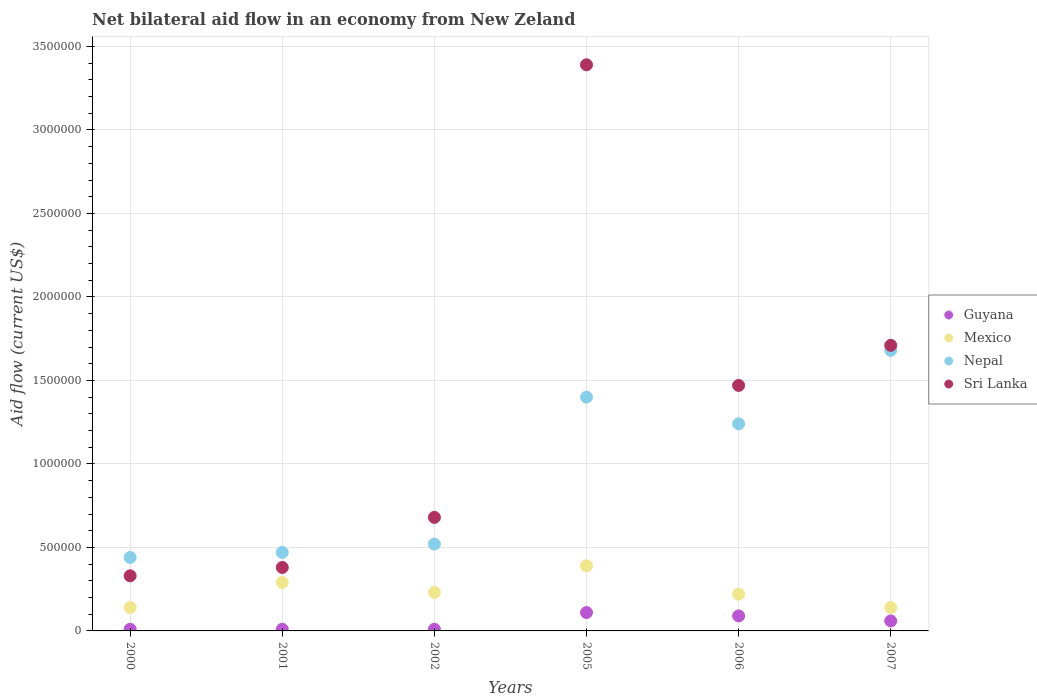What is the net bilateral aid flow in Guyana in 2002?
Offer a terse response. 10000. Across all years, what is the maximum net bilateral aid flow in Sri Lanka?
Provide a short and direct response. 3.39e+06. In which year was the net bilateral aid flow in Mexico maximum?
Your answer should be compact. 2005. In which year was the net bilateral aid flow in Mexico minimum?
Your answer should be very brief. 2000. What is the total net bilateral aid flow in Nepal in the graph?
Your answer should be very brief. 5.75e+06. What is the difference between the net bilateral aid flow in Sri Lanka in 2002 and that in 2005?
Your answer should be compact. -2.71e+06. What is the difference between the net bilateral aid flow in Nepal in 2005 and the net bilateral aid flow in Guyana in 2001?
Offer a very short reply. 1.39e+06. What is the average net bilateral aid flow in Sri Lanka per year?
Provide a succinct answer. 1.33e+06. What is the ratio of the net bilateral aid flow in Guyana in 2000 to that in 2005?
Offer a terse response. 0.09. What is the difference between the highest and the second highest net bilateral aid flow in Sri Lanka?
Your answer should be very brief. 1.68e+06. What is the difference between the highest and the lowest net bilateral aid flow in Nepal?
Your answer should be compact. 1.24e+06. Is the sum of the net bilateral aid flow in Nepal in 2001 and 2002 greater than the maximum net bilateral aid flow in Guyana across all years?
Ensure brevity in your answer.  Yes. Is it the case that in every year, the sum of the net bilateral aid flow in Mexico and net bilateral aid flow in Nepal  is greater than the sum of net bilateral aid flow in Guyana and net bilateral aid flow in Sri Lanka?
Provide a succinct answer. Yes. Does the net bilateral aid flow in Guyana monotonically increase over the years?
Your answer should be very brief. No. Is the net bilateral aid flow in Nepal strictly greater than the net bilateral aid flow in Guyana over the years?
Offer a terse response. Yes. How many dotlines are there?
Keep it short and to the point. 4. What is the difference between two consecutive major ticks on the Y-axis?
Offer a terse response. 5.00e+05. Does the graph contain any zero values?
Offer a terse response. No. What is the title of the graph?
Offer a terse response. Net bilateral aid flow in an economy from New Zeland. What is the Aid flow (current US$) in Guyana in 2000?
Make the answer very short. 10000. What is the Aid flow (current US$) of Mexico in 2000?
Keep it short and to the point. 1.40e+05. What is the Aid flow (current US$) in Nepal in 2000?
Your response must be concise. 4.40e+05. What is the Aid flow (current US$) in Sri Lanka in 2001?
Your response must be concise. 3.80e+05. What is the Aid flow (current US$) in Mexico in 2002?
Offer a terse response. 2.30e+05. What is the Aid flow (current US$) in Nepal in 2002?
Provide a succinct answer. 5.20e+05. What is the Aid flow (current US$) in Sri Lanka in 2002?
Your answer should be very brief. 6.80e+05. What is the Aid flow (current US$) in Guyana in 2005?
Offer a terse response. 1.10e+05. What is the Aid flow (current US$) in Nepal in 2005?
Your answer should be very brief. 1.40e+06. What is the Aid flow (current US$) of Sri Lanka in 2005?
Your answer should be very brief. 3.39e+06. What is the Aid flow (current US$) of Guyana in 2006?
Offer a very short reply. 9.00e+04. What is the Aid flow (current US$) of Nepal in 2006?
Keep it short and to the point. 1.24e+06. What is the Aid flow (current US$) in Sri Lanka in 2006?
Your response must be concise. 1.47e+06. What is the Aid flow (current US$) of Mexico in 2007?
Offer a very short reply. 1.40e+05. What is the Aid flow (current US$) in Nepal in 2007?
Ensure brevity in your answer.  1.68e+06. What is the Aid flow (current US$) in Sri Lanka in 2007?
Your response must be concise. 1.71e+06. Across all years, what is the maximum Aid flow (current US$) in Nepal?
Give a very brief answer. 1.68e+06. Across all years, what is the maximum Aid flow (current US$) in Sri Lanka?
Provide a succinct answer. 3.39e+06. Across all years, what is the minimum Aid flow (current US$) of Nepal?
Give a very brief answer. 4.40e+05. Across all years, what is the minimum Aid flow (current US$) of Sri Lanka?
Ensure brevity in your answer.  3.30e+05. What is the total Aid flow (current US$) of Guyana in the graph?
Your answer should be very brief. 2.90e+05. What is the total Aid flow (current US$) in Mexico in the graph?
Ensure brevity in your answer.  1.41e+06. What is the total Aid flow (current US$) in Nepal in the graph?
Provide a succinct answer. 5.75e+06. What is the total Aid flow (current US$) of Sri Lanka in the graph?
Offer a terse response. 7.96e+06. What is the difference between the Aid flow (current US$) of Nepal in 2000 and that in 2001?
Provide a succinct answer. -3.00e+04. What is the difference between the Aid flow (current US$) in Nepal in 2000 and that in 2002?
Provide a short and direct response. -8.00e+04. What is the difference between the Aid flow (current US$) in Sri Lanka in 2000 and that in 2002?
Offer a very short reply. -3.50e+05. What is the difference between the Aid flow (current US$) of Nepal in 2000 and that in 2005?
Provide a succinct answer. -9.60e+05. What is the difference between the Aid flow (current US$) in Sri Lanka in 2000 and that in 2005?
Make the answer very short. -3.06e+06. What is the difference between the Aid flow (current US$) in Guyana in 2000 and that in 2006?
Offer a terse response. -8.00e+04. What is the difference between the Aid flow (current US$) in Nepal in 2000 and that in 2006?
Your answer should be compact. -8.00e+05. What is the difference between the Aid flow (current US$) in Sri Lanka in 2000 and that in 2006?
Give a very brief answer. -1.14e+06. What is the difference between the Aid flow (current US$) in Nepal in 2000 and that in 2007?
Your answer should be compact. -1.24e+06. What is the difference between the Aid flow (current US$) in Sri Lanka in 2000 and that in 2007?
Offer a very short reply. -1.38e+06. What is the difference between the Aid flow (current US$) in Mexico in 2001 and that in 2002?
Make the answer very short. 6.00e+04. What is the difference between the Aid flow (current US$) in Sri Lanka in 2001 and that in 2002?
Keep it short and to the point. -3.00e+05. What is the difference between the Aid flow (current US$) of Guyana in 2001 and that in 2005?
Keep it short and to the point. -1.00e+05. What is the difference between the Aid flow (current US$) in Nepal in 2001 and that in 2005?
Provide a short and direct response. -9.30e+05. What is the difference between the Aid flow (current US$) of Sri Lanka in 2001 and that in 2005?
Keep it short and to the point. -3.01e+06. What is the difference between the Aid flow (current US$) in Guyana in 2001 and that in 2006?
Provide a succinct answer. -8.00e+04. What is the difference between the Aid flow (current US$) of Mexico in 2001 and that in 2006?
Your answer should be very brief. 7.00e+04. What is the difference between the Aid flow (current US$) in Nepal in 2001 and that in 2006?
Your response must be concise. -7.70e+05. What is the difference between the Aid flow (current US$) of Sri Lanka in 2001 and that in 2006?
Ensure brevity in your answer.  -1.09e+06. What is the difference between the Aid flow (current US$) in Mexico in 2001 and that in 2007?
Offer a very short reply. 1.50e+05. What is the difference between the Aid flow (current US$) in Nepal in 2001 and that in 2007?
Your answer should be very brief. -1.21e+06. What is the difference between the Aid flow (current US$) in Sri Lanka in 2001 and that in 2007?
Make the answer very short. -1.33e+06. What is the difference between the Aid flow (current US$) in Guyana in 2002 and that in 2005?
Provide a short and direct response. -1.00e+05. What is the difference between the Aid flow (current US$) of Mexico in 2002 and that in 2005?
Provide a short and direct response. -1.60e+05. What is the difference between the Aid flow (current US$) of Nepal in 2002 and that in 2005?
Offer a very short reply. -8.80e+05. What is the difference between the Aid flow (current US$) in Sri Lanka in 2002 and that in 2005?
Offer a terse response. -2.71e+06. What is the difference between the Aid flow (current US$) of Guyana in 2002 and that in 2006?
Provide a short and direct response. -8.00e+04. What is the difference between the Aid flow (current US$) of Nepal in 2002 and that in 2006?
Offer a very short reply. -7.20e+05. What is the difference between the Aid flow (current US$) of Sri Lanka in 2002 and that in 2006?
Provide a succinct answer. -7.90e+05. What is the difference between the Aid flow (current US$) of Guyana in 2002 and that in 2007?
Your answer should be compact. -5.00e+04. What is the difference between the Aid flow (current US$) of Nepal in 2002 and that in 2007?
Make the answer very short. -1.16e+06. What is the difference between the Aid flow (current US$) in Sri Lanka in 2002 and that in 2007?
Offer a terse response. -1.03e+06. What is the difference between the Aid flow (current US$) of Nepal in 2005 and that in 2006?
Give a very brief answer. 1.60e+05. What is the difference between the Aid flow (current US$) in Sri Lanka in 2005 and that in 2006?
Keep it short and to the point. 1.92e+06. What is the difference between the Aid flow (current US$) in Nepal in 2005 and that in 2007?
Make the answer very short. -2.80e+05. What is the difference between the Aid flow (current US$) in Sri Lanka in 2005 and that in 2007?
Your answer should be compact. 1.68e+06. What is the difference between the Aid flow (current US$) in Guyana in 2006 and that in 2007?
Give a very brief answer. 3.00e+04. What is the difference between the Aid flow (current US$) in Nepal in 2006 and that in 2007?
Your answer should be compact. -4.40e+05. What is the difference between the Aid flow (current US$) of Sri Lanka in 2006 and that in 2007?
Keep it short and to the point. -2.40e+05. What is the difference between the Aid flow (current US$) in Guyana in 2000 and the Aid flow (current US$) in Mexico in 2001?
Make the answer very short. -2.80e+05. What is the difference between the Aid flow (current US$) of Guyana in 2000 and the Aid flow (current US$) of Nepal in 2001?
Make the answer very short. -4.60e+05. What is the difference between the Aid flow (current US$) of Guyana in 2000 and the Aid flow (current US$) of Sri Lanka in 2001?
Give a very brief answer. -3.70e+05. What is the difference between the Aid flow (current US$) of Mexico in 2000 and the Aid flow (current US$) of Nepal in 2001?
Keep it short and to the point. -3.30e+05. What is the difference between the Aid flow (current US$) in Nepal in 2000 and the Aid flow (current US$) in Sri Lanka in 2001?
Provide a succinct answer. 6.00e+04. What is the difference between the Aid flow (current US$) of Guyana in 2000 and the Aid flow (current US$) of Nepal in 2002?
Your answer should be very brief. -5.10e+05. What is the difference between the Aid flow (current US$) in Guyana in 2000 and the Aid flow (current US$) in Sri Lanka in 2002?
Your answer should be very brief. -6.70e+05. What is the difference between the Aid flow (current US$) of Mexico in 2000 and the Aid flow (current US$) of Nepal in 2002?
Ensure brevity in your answer.  -3.80e+05. What is the difference between the Aid flow (current US$) in Mexico in 2000 and the Aid flow (current US$) in Sri Lanka in 2002?
Make the answer very short. -5.40e+05. What is the difference between the Aid flow (current US$) of Nepal in 2000 and the Aid flow (current US$) of Sri Lanka in 2002?
Your answer should be very brief. -2.40e+05. What is the difference between the Aid flow (current US$) in Guyana in 2000 and the Aid flow (current US$) in Mexico in 2005?
Provide a short and direct response. -3.80e+05. What is the difference between the Aid flow (current US$) of Guyana in 2000 and the Aid flow (current US$) of Nepal in 2005?
Give a very brief answer. -1.39e+06. What is the difference between the Aid flow (current US$) in Guyana in 2000 and the Aid flow (current US$) in Sri Lanka in 2005?
Offer a terse response. -3.38e+06. What is the difference between the Aid flow (current US$) of Mexico in 2000 and the Aid flow (current US$) of Nepal in 2005?
Ensure brevity in your answer.  -1.26e+06. What is the difference between the Aid flow (current US$) of Mexico in 2000 and the Aid flow (current US$) of Sri Lanka in 2005?
Provide a succinct answer. -3.25e+06. What is the difference between the Aid flow (current US$) in Nepal in 2000 and the Aid flow (current US$) in Sri Lanka in 2005?
Your answer should be very brief. -2.95e+06. What is the difference between the Aid flow (current US$) in Guyana in 2000 and the Aid flow (current US$) in Nepal in 2006?
Ensure brevity in your answer.  -1.23e+06. What is the difference between the Aid flow (current US$) in Guyana in 2000 and the Aid flow (current US$) in Sri Lanka in 2006?
Provide a short and direct response. -1.46e+06. What is the difference between the Aid flow (current US$) of Mexico in 2000 and the Aid flow (current US$) of Nepal in 2006?
Your response must be concise. -1.10e+06. What is the difference between the Aid flow (current US$) of Mexico in 2000 and the Aid flow (current US$) of Sri Lanka in 2006?
Your response must be concise. -1.33e+06. What is the difference between the Aid flow (current US$) of Nepal in 2000 and the Aid flow (current US$) of Sri Lanka in 2006?
Your answer should be very brief. -1.03e+06. What is the difference between the Aid flow (current US$) of Guyana in 2000 and the Aid flow (current US$) of Nepal in 2007?
Your answer should be very brief. -1.67e+06. What is the difference between the Aid flow (current US$) in Guyana in 2000 and the Aid flow (current US$) in Sri Lanka in 2007?
Provide a succinct answer. -1.70e+06. What is the difference between the Aid flow (current US$) in Mexico in 2000 and the Aid flow (current US$) in Nepal in 2007?
Offer a very short reply. -1.54e+06. What is the difference between the Aid flow (current US$) of Mexico in 2000 and the Aid flow (current US$) of Sri Lanka in 2007?
Your response must be concise. -1.57e+06. What is the difference between the Aid flow (current US$) of Nepal in 2000 and the Aid flow (current US$) of Sri Lanka in 2007?
Give a very brief answer. -1.27e+06. What is the difference between the Aid flow (current US$) in Guyana in 2001 and the Aid flow (current US$) in Mexico in 2002?
Keep it short and to the point. -2.20e+05. What is the difference between the Aid flow (current US$) in Guyana in 2001 and the Aid flow (current US$) in Nepal in 2002?
Ensure brevity in your answer.  -5.10e+05. What is the difference between the Aid flow (current US$) in Guyana in 2001 and the Aid flow (current US$) in Sri Lanka in 2002?
Keep it short and to the point. -6.70e+05. What is the difference between the Aid flow (current US$) in Mexico in 2001 and the Aid flow (current US$) in Nepal in 2002?
Keep it short and to the point. -2.30e+05. What is the difference between the Aid flow (current US$) of Mexico in 2001 and the Aid flow (current US$) of Sri Lanka in 2002?
Provide a short and direct response. -3.90e+05. What is the difference between the Aid flow (current US$) of Guyana in 2001 and the Aid flow (current US$) of Mexico in 2005?
Your answer should be compact. -3.80e+05. What is the difference between the Aid flow (current US$) in Guyana in 2001 and the Aid flow (current US$) in Nepal in 2005?
Make the answer very short. -1.39e+06. What is the difference between the Aid flow (current US$) of Guyana in 2001 and the Aid flow (current US$) of Sri Lanka in 2005?
Provide a succinct answer. -3.38e+06. What is the difference between the Aid flow (current US$) in Mexico in 2001 and the Aid flow (current US$) in Nepal in 2005?
Your answer should be compact. -1.11e+06. What is the difference between the Aid flow (current US$) of Mexico in 2001 and the Aid flow (current US$) of Sri Lanka in 2005?
Keep it short and to the point. -3.10e+06. What is the difference between the Aid flow (current US$) in Nepal in 2001 and the Aid flow (current US$) in Sri Lanka in 2005?
Ensure brevity in your answer.  -2.92e+06. What is the difference between the Aid flow (current US$) in Guyana in 2001 and the Aid flow (current US$) in Mexico in 2006?
Give a very brief answer. -2.10e+05. What is the difference between the Aid flow (current US$) of Guyana in 2001 and the Aid flow (current US$) of Nepal in 2006?
Make the answer very short. -1.23e+06. What is the difference between the Aid flow (current US$) in Guyana in 2001 and the Aid flow (current US$) in Sri Lanka in 2006?
Keep it short and to the point. -1.46e+06. What is the difference between the Aid flow (current US$) of Mexico in 2001 and the Aid flow (current US$) of Nepal in 2006?
Ensure brevity in your answer.  -9.50e+05. What is the difference between the Aid flow (current US$) in Mexico in 2001 and the Aid flow (current US$) in Sri Lanka in 2006?
Your response must be concise. -1.18e+06. What is the difference between the Aid flow (current US$) in Guyana in 2001 and the Aid flow (current US$) in Mexico in 2007?
Offer a terse response. -1.30e+05. What is the difference between the Aid flow (current US$) of Guyana in 2001 and the Aid flow (current US$) of Nepal in 2007?
Your answer should be compact. -1.67e+06. What is the difference between the Aid flow (current US$) of Guyana in 2001 and the Aid flow (current US$) of Sri Lanka in 2007?
Offer a very short reply. -1.70e+06. What is the difference between the Aid flow (current US$) in Mexico in 2001 and the Aid flow (current US$) in Nepal in 2007?
Provide a short and direct response. -1.39e+06. What is the difference between the Aid flow (current US$) in Mexico in 2001 and the Aid flow (current US$) in Sri Lanka in 2007?
Your response must be concise. -1.42e+06. What is the difference between the Aid flow (current US$) of Nepal in 2001 and the Aid flow (current US$) of Sri Lanka in 2007?
Offer a terse response. -1.24e+06. What is the difference between the Aid flow (current US$) in Guyana in 2002 and the Aid flow (current US$) in Mexico in 2005?
Make the answer very short. -3.80e+05. What is the difference between the Aid flow (current US$) of Guyana in 2002 and the Aid flow (current US$) of Nepal in 2005?
Your answer should be very brief. -1.39e+06. What is the difference between the Aid flow (current US$) of Guyana in 2002 and the Aid flow (current US$) of Sri Lanka in 2005?
Ensure brevity in your answer.  -3.38e+06. What is the difference between the Aid flow (current US$) of Mexico in 2002 and the Aid flow (current US$) of Nepal in 2005?
Offer a terse response. -1.17e+06. What is the difference between the Aid flow (current US$) of Mexico in 2002 and the Aid flow (current US$) of Sri Lanka in 2005?
Ensure brevity in your answer.  -3.16e+06. What is the difference between the Aid flow (current US$) in Nepal in 2002 and the Aid flow (current US$) in Sri Lanka in 2005?
Ensure brevity in your answer.  -2.87e+06. What is the difference between the Aid flow (current US$) in Guyana in 2002 and the Aid flow (current US$) in Mexico in 2006?
Offer a very short reply. -2.10e+05. What is the difference between the Aid flow (current US$) of Guyana in 2002 and the Aid flow (current US$) of Nepal in 2006?
Your answer should be very brief. -1.23e+06. What is the difference between the Aid flow (current US$) of Guyana in 2002 and the Aid flow (current US$) of Sri Lanka in 2006?
Provide a succinct answer. -1.46e+06. What is the difference between the Aid flow (current US$) in Mexico in 2002 and the Aid flow (current US$) in Nepal in 2006?
Provide a succinct answer. -1.01e+06. What is the difference between the Aid flow (current US$) of Mexico in 2002 and the Aid flow (current US$) of Sri Lanka in 2006?
Make the answer very short. -1.24e+06. What is the difference between the Aid flow (current US$) of Nepal in 2002 and the Aid flow (current US$) of Sri Lanka in 2006?
Ensure brevity in your answer.  -9.50e+05. What is the difference between the Aid flow (current US$) in Guyana in 2002 and the Aid flow (current US$) in Nepal in 2007?
Offer a very short reply. -1.67e+06. What is the difference between the Aid flow (current US$) in Guyana in 2002 and the Aid flow (current US$) in Sri Lanka in 2007?
Your answer should be compact. -1.70e+06. What is the difference between the Aid flow (current US$) of Mexico in 2002 and the Aid flow (current US$) of Nepal in 2007?
Ensure brevity in your answer.  -1.45e+06. What is the difference between the Aid flow (current US$) in Mexico in 2002 and the Aid flow (current US$) in Sri Lanka in 2007?
Offer a terse response. -1.48e+06. What is the difference between the Aid flow (current US$) of Nepal in 2002 and the Aid flow (current US$) of Sri Lanka in 2007?
Ensure brevity in your answer.  -1.19e+06. What is the difference between the Aid flow (current US$) of Guyana in 2005 and the Aid flow (current US$) of Nepal in 2006?
Offer a very short reply. -1.13e+06. What is the difference between the Aid flow (current US$) in Guyana in 2005 and the Aid flow (current US$) in Sri Lanka in 2006?
Offer a very short reply. -1.36e+06. What is the difference between the Aid flow (current US$) of Mexico in 2005 and the Aid flow (current US$) of Nepal in 2006?
Offer a terse response. -8.50e+05. What is the difference between the Aid flow (current US$) of Mexico in 2005 and the Aid flow (current US$) of Sri Lanka in 2006?
Keep it short and to the point. -1.08e+06. What is the difference between the Aid flow (current US$) of Guyana in 2005 and the Aid flow (current US$) of Mexico in 2007?
Keep it short and to the point. -3.00e+04. What is the difference between the Aid flow (current US$) of Guyana in 2005 and the Aid flow (current US$) of Nepal in 2007?
Keep it short and to the point. -1.57e+06. What is the difference between the Aid flow (current US$) in Guyana in 2005 and the Aid flow (current US$) in Sri Lanka in 2007?
Ensure brevity in your answer.  -1.60e+06. What is the difference between the Aid flow (current US$) in Mexico in 2005 and the Aid flow (current US$) in Nepal in 2007?
Ensure brevity in your answer.  -1.29e+06. What is the difference between the Aid flow (current US$) in Mexico in 2005 and the Aid flow (current US$) in Sri Lanka in 2007?
Provide a succinct answer. -1.32e+06. What is the difference between the Aid flow (current US$) of Nepal in 2005 and the Aid flow (current US$) of Sri Lanka in 2007?
Provide a succinct answer. -3.10e+05. What is the difference between the Aid flow (current US$) of Guyana in 2006 and the Aid flow (current US$) of Nepal in 2007?
Offer a very short reply. -1.59e+06. What is the difference between the Aid flow (current US$) of Guyana in 2006 and the Aid flow (current US$) of Sri Lanka in 2007?
Your response must be concise. -1.62e+06. What is the difference between the Aid flow (current US$) in Mexico in 2006 and the Aid flow (current US$) in Nepal in 2007?
Make the answer very short. -1.46e+06. What is the difference between the Aid flow (current US$) in Mexico in 2006 and the Aid flow (current US$) in Sri Lanka in 2007?
Offer a terse response. -1.49e+06. What is the difference between the Aid flow (current US$) in Nepal in 2006 and the Aid flow (current US$) in Sri Lanka in 2007?
Offer a terse response. -4.70e+05. What is the average Aid flow (current US$) of Guyana per year?
Your response must be concise. 4.83e+04. What is the average Aid flow (current US$) of Mexico per year?
Provide a short and direct response. 2.35e+05. What is the average Aid flow (current US$) in Nepal per year?
Provide a short and direct response. 9.58e+05. What is the average Aid flow (current US$) of Sri Lanka per year?
Make the answer very short. 1.33e+06. In the year 2000, what is the difference between the Aid flow (current US$) in Guyana and Aid flow (current US$) in Mexico?
Give a very brief answer. -1.30e+05. In the year 2000, what is the difference between the Aid flow (current US$) of Guyana and Aid flow (current US$) of Nepal?
Offer a very short reply. -4.30e+05. In the year 2000, what is the difference between the Aid flow (current US$) of Guyana and Aid flow (current US$) of Sri Lanka?
Your answer should be compact. -3.20e+05. In the year 2000, what is the difference between the Aid flow (current US$) in Nepal and Aid flow (current US$) in Sri Lanka?
Make the answer very short. 1.10e+05. In the year 2001, what is the difference between the Aid flow (current US$) of Guyana and Aid flow (current US$) of Mexico?
Offer a terse response. -2.80e+05. In the year 2001, what is the difference between the Aid flow (current US$) of Guyana and Aid flow (current US$) of Nepal?
Keep it short and to the point. -4.60e+05. In the year 2001, what is the difference between the Aid flow (current US$) in Guyana and Aid flow (current US$) in Sri Lanka?
Make the answer very short. -3.70e+05. In the year 2001, what is the difference between the Aid flow (current US$) in Mexico and Aid flow (current US$) in Nepal?
Keep it short and to the point. -1.80e+05. In the year 2001, what is the difference between the Aid flow (current US$) in Mexico and Aid flow (current US$) in Sri Lanka?
Give a very brief answer. -9.00e+04. In the year 2001, what is the difference between the Aid flow (current US$) in Nepal and Aid flow (current US$) in Sri Lanka?
Keep it short and to the point. 9.00e+04. In the year 2002, what is the difference between the Aid flow (current US$) of Guyana and Aid flow (current US$) of Mexico?
Your response must be concise. -2.20e+05. In the year 2002, what is the difference between the Aid flow (current US$) in Guyana and Aid flow (current US$) in Nepal?
Your answer should be very brief. -5.10e+05. In the year 2002, what is the difference between the Aid flow (current US$) of Guyana and Aid flow (current US$) of Sri Lanka?
Offer a very short reply. -6.70e+05. In the year 2002, what is the difference between the Aid flow (current US$) of Mexico and Aid flow (current US$) of Nepal?
Your response must be concise. -2.90e+05. In the year 2002, what is the difference between the Aid flow (current US$) of Mexico and Aid flow (current US$) of Sri Lanka?
Give a very brief answer. -4.50e+05. In the year 2005, what is the difference between the Aid flow (current US$) of Guyana and Aid flow (current US$) of Mexico?
Give a very brief answer. -2.80e+05. In the year 2005, what is the difference between the Aid flow (current US$) in Guyana and Aid flow (current US$) in Nepal?
Give a very brief answer. -1.29e+06. In the year 2005, what is the difference between the Aid flow (current US$) of Guyana and Aid flow (current US$) of Sri Lanka?
Offer a very short reply. -3.28e+06. In the year 2005, what is the difference between the Aid flow (current US$) in Mexico and Aid flow (current US$) in Nepal?
Ensure brevity in your answer.  -1.01e+06. In the year 2005, what is the difference between the Aid flow (current US$) in Mexico and Aid flow (current US$) in Sri Lanka?
Your answer should be very brief. -3.00e+06. In the year 2005, what is the difference between the Aid flow (current US$) in Nepal and Aid flow (current US$) in Sri Lanka?
Your answer should be compact. -1.99e+06. In the year 2006, what is the difference between the Aid flow (current US$) of Guyana and Aid flow (current US$) of Mexico?
Offer a very short reply. -1.30e+05. In the year 2006, what is the difference between the Aid flow (current US$) of Guyana and Aid flow (current US$) of Nepal?
Provide a succinct answer. -1.15e+06. In the year 2006, what is the difference between the Aid flow (current US$) in Guyana and Aid flow (current US$) in Sri Lanka?
Keep it short and to the point. -1.38e+06. In the year 2006, what is the difference between the Aid flow (current US$) of Mexico and Aid flow (current US$) of Nepal?
Provide a succinct answer. -1.02e+06. In the year 2006, what is the difference between the Aid flow (current US$) in Mexico and Aid flow (current US$) in Sri Lanka?
Provide a short and direct response. -1.25e+06. In the year 2006, what is the difference between the Aid flow (current US$) in Nepal and Aid flow (current US$) in Sri Lanka?
Offer a terse response. -2.30e+05. In the year 2007, what is the difference between the Aid flow (current US$) of Guyana and Aid flow (current US$) of Mexico?
Provide a short and direct response. -8.00e+04. In the year 2007, what is the difference between the Aid flow (current US$) in Guyana and Aid flow (current US$) in Nepal?
Provide a succinct answer. -1.62e+06. In the year 2007, what is the difference between the Aid flow (current US$) of Guyana and Aid flow (current US$) of Sri Lanka?
Provide a succinct answer. -1.65e+06. In the year 2007, what is the difference between the Aid flow (current US$) of Mexico and Aid flow (current US$) of Nepal?
Ensure brevity in your answer.  -1.54e+06. In the year 2007, what is the difference between the Aid flow (current US$) in Mexico and Aid flow (current US$) in Sri Lanka?
Provide a succinct answer. -1.57e+06. What is the ratio of the Aid flow (current US$) of Mexico in 2000 to that in 2001?
Make the answer very short. 0.48. What is the ratio of the Aid flow (current US$) in Nepal in 2000 to that in 2001?
Make the answer very short. 0.94. What is the ratio of the Aid flow (current US$) of Sri Lanka in 2000 to that in 2001?
Provide a short and direct response. 0.87. What is the ratio of the Aid flow (current US$) of Guyana in 2000 to that in 2002?
Your answer should be very brief. 1. What is the ratio of the Aid flow (current US$) of Mexico in 2000 to that in 2002?
Offer a very short reply. 0.61. What is the ratio of the Aid flow (current US$) in Nepal in 2000 to that in 2002?
Give a very brief answer. 0.85. What is the ratio of the Aid flow (current US$) of Sri Lanka in 2000 to that in 2002?
Ensure brevity in your answer.  0.49. What is the ratio of the Aid flow (current US$) in Guyana in 2000 to that in 2005?
Your response must be concise. 0.09. What is the ratio of the Aid flow (current US$) in Mexico in 2000 to that in 2005?
Provide a short and direct response. 0.36. What is the ratio of the Aid flow (current US$) of Nepal in 2000 to that in 2005?
Offer a terse response. 0.31. What is the ratio of the Aid flow (current US$) of Sri Lanka in 2000 to that in 2005?
Offer a terse response. 0.1. What is the ratio of the Aid flow (current US$) of Guyana in 2000 to that in 2006?
Your response must be concise. 0.11. What is the ratio of the Aid flow (current US$) in Mexico in 2000 to that in 2006?
Your response must be concise. 0.64. What is the ratio of the Aid flow (current US$) of Nepal in 2000 to that in 2006?
Make the answer very short. 0.35. What is the ratio of the Aid flow (current US$) in Sri Lanka in 2000 to that in 2006?
Provide a succinct answer. 0.22. What is the ratio of the Aid flow (current US$) in Guyana in 2000 to that in 2007?
Provide a short and direct response. 0.17. What is the ratio of the Aid flow (current US$) of Mexico in 2000 to that in 2007?
Your answer should be very brief. 1. What is the ratio of the Aid flow (current US$) in Nepal in 2000 to that in 2007?
Provide a short and direct response. 0.26. What is the ratio of the Aid flow (current US$) of Sri Lanka in 2000 to that in 2007?
Your answer should be compact. 0.19. What is the ratio of the Aid flow (current US$) in Mexico in 2001 to that in 2002?
Your answer should be very brief. 1.26. What is the ratio of the Aid flow (current US$) in Nepal in 2001 to that in 2002?
Offer a terse response. 0.9. What is the ratio of the Aid flow (current US$) of Sri Lanka in 2001 to that in 2002?
Your response must be concise. 0.56. What is the ratio of the Aid flow (current US$) in Guyana in 2001 to that in 2005?
Your answer should be compact. 0.09. What is the ratio of the Aid flow (current US$) in Mexico in 2001 to that in 2005?
Provide a short and direct response. 0.74. What is the ratio of the Aid flow (current US$) in Nepal in 2001 to that in 2005?
Make the answer very short. 0.34. What is the ratio of the Aid flow (current US$) of Sri Lanka in 2001 to that in 2005?
Your answer should be very brief. 0.11. What is the ratio of the Aid flow (current US$) of Guyana in 2001 to that in 2006?
Make the answer very short. 0.11. What is the ratio of the Aid flow (current US$) in Mexico in 2001 to that in 2006?
Your response must be concise. 1.32. What is the ratio of the Aid flow (current US$) in Nepal in 2001 to that in 2006?
Your answer should be compact. 0.38. What is the ratio of the Aid flow (current US$) in Sri Lanka in 2001 to that in 2006?
Ensure brevity in your answer.  0.26. What is the ratio of the Aid flow (current US$) in Guyana in 2001 to that in 2007?
Your answer should be very brief. 0.17. What is the ratio of the Aid flow (current US$) in Mexico in 2001 to that in 2007?
Keep it short and to the point. 2.07. What is the ratio of the Aid flow (current US$) of Nepal in 2001 to that in 2007?
Your response must be concise. 0.28. What is the ratio of the Aid flow (current US$) of Sri Lanka in 2001 to that in 2007?
Offer a terse response. 0.22. What is the ratio of the Aid flow (current US$) in Guyana in 2002 to that in 2005?
Your answer should be very brief. 0.09. What is the ratio of the Aid flow (current US$) of Mexico in 2002 to that in 2005?
Make the answer very short. 0.59. What is the ratio of the Aid flow (current US$) of Nepal in 2002 to that in 2005?
Offer a very short reply. 0.37. What is the ratio of the Aid flow (current US$) of Sri Lanka in 2002 to that in 2005?
Provide a short and direct response. 0.2. What is the ratio of the Aid flow (current US$) of Mexico in 2002 to that in 2006?
Ensure brevity in your answer.  1.05. What is the ratio of the Aid flow (current US$) of Nepal in 2002 to that in 2006?
Your answer should be very brief. 0.42. What is the ratio of the Aid flow (current US$) in Sri Lanka in 2002 to that in 2006?
Provide a succinct answer. 0.46. What is the ratio of the Aid flow (current US$) of Mexico in 2002 to that in 2007?
Offer a very short reply. 1.64. What is the ratio of the Aid flow (current US$) in Nepal in 2002 to that in 2007?
Your answer should be compact. 0.31. What is the ratio of the Aid flow (current US$) in Sri Lanka in 2002 to that in 2007?
Your answer should be very brief. 0.4. What is the ratio of the Aid flow (current US$) in Guyana in 2005 to that in 2006?
Offer a terse response. 1.22. What is the ratio of the Aid flow (current US$) in Mexico in 2005 to that in 2006?
Provide a short and direct response. 1.77. What is the ratio of the Aid flow (current US$) of Nepal in 2005 to that in 2006?
Offer a terse response. 1.13. What is the ratio of the Aid flow (current US$) in Sri Lanka in 2005 to that in 2006?
Your response must be concise. 2.31. What is the ratio of the Aid flow (current US$) of Guyana in 2005 to that in 2007?
Provide a short and direct response. 1.83. What is the ratio of the Aid flow (current US$) of Mexico in 2005 to that in 2007?
Offer a terse response. 2.79. What is the ratio of the Aid flow (current US$) in Sri Lanka in 2005 to that in 2007?
Provide a short and direct response. 1.98. What is the ratio of the Aid flow (current US$) of Mexico in 2006 to that in 2007?
Give a very brief answer. 1.57. What is the ratio of the Aid flow (current US$) of Nepal in 2006 to that in 2007?
Make the answer very short. 0.74. What is the ratio of the Aid flow (current US$) of Sri Lanka in 2006 to that in 2007?
Make the answer very short. 0.86. What is the difference between the highest and the second highest Aid flow (current US$) in Mexico?
Your answer should be compact. 1.00e+05. What is the difference between the highest and the second highest Aid flow (current US$) of Sri Lanka?
Your response must be concise. 1.68e+06. What is the difference between the highest and the lowest Aid flow (current US$) in Mexico?
Give a very brief answer. 2.50e+05. What is the difference between the highest and the lowest Aid flow (current US$) of Nepal?
Give a very brief answer. 1.24e+06. What is the difference between the highest and the lowest Aid flow (current US$) of Sri Lanka?
Your answer should be compact. 3.06e+06. 